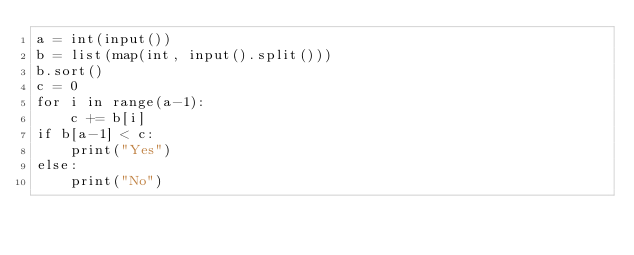Convert code to text. <code><loc_0><loc_0><loc_500><loc_500><_Python_>a = int(input())
b = list(map(int, input().split()))
b.sort()
c = 0
for i in range(a-1):
    c += b[i]
if b[a-1] < c:
    print("Yes")
else:
    print("No")
</code> 